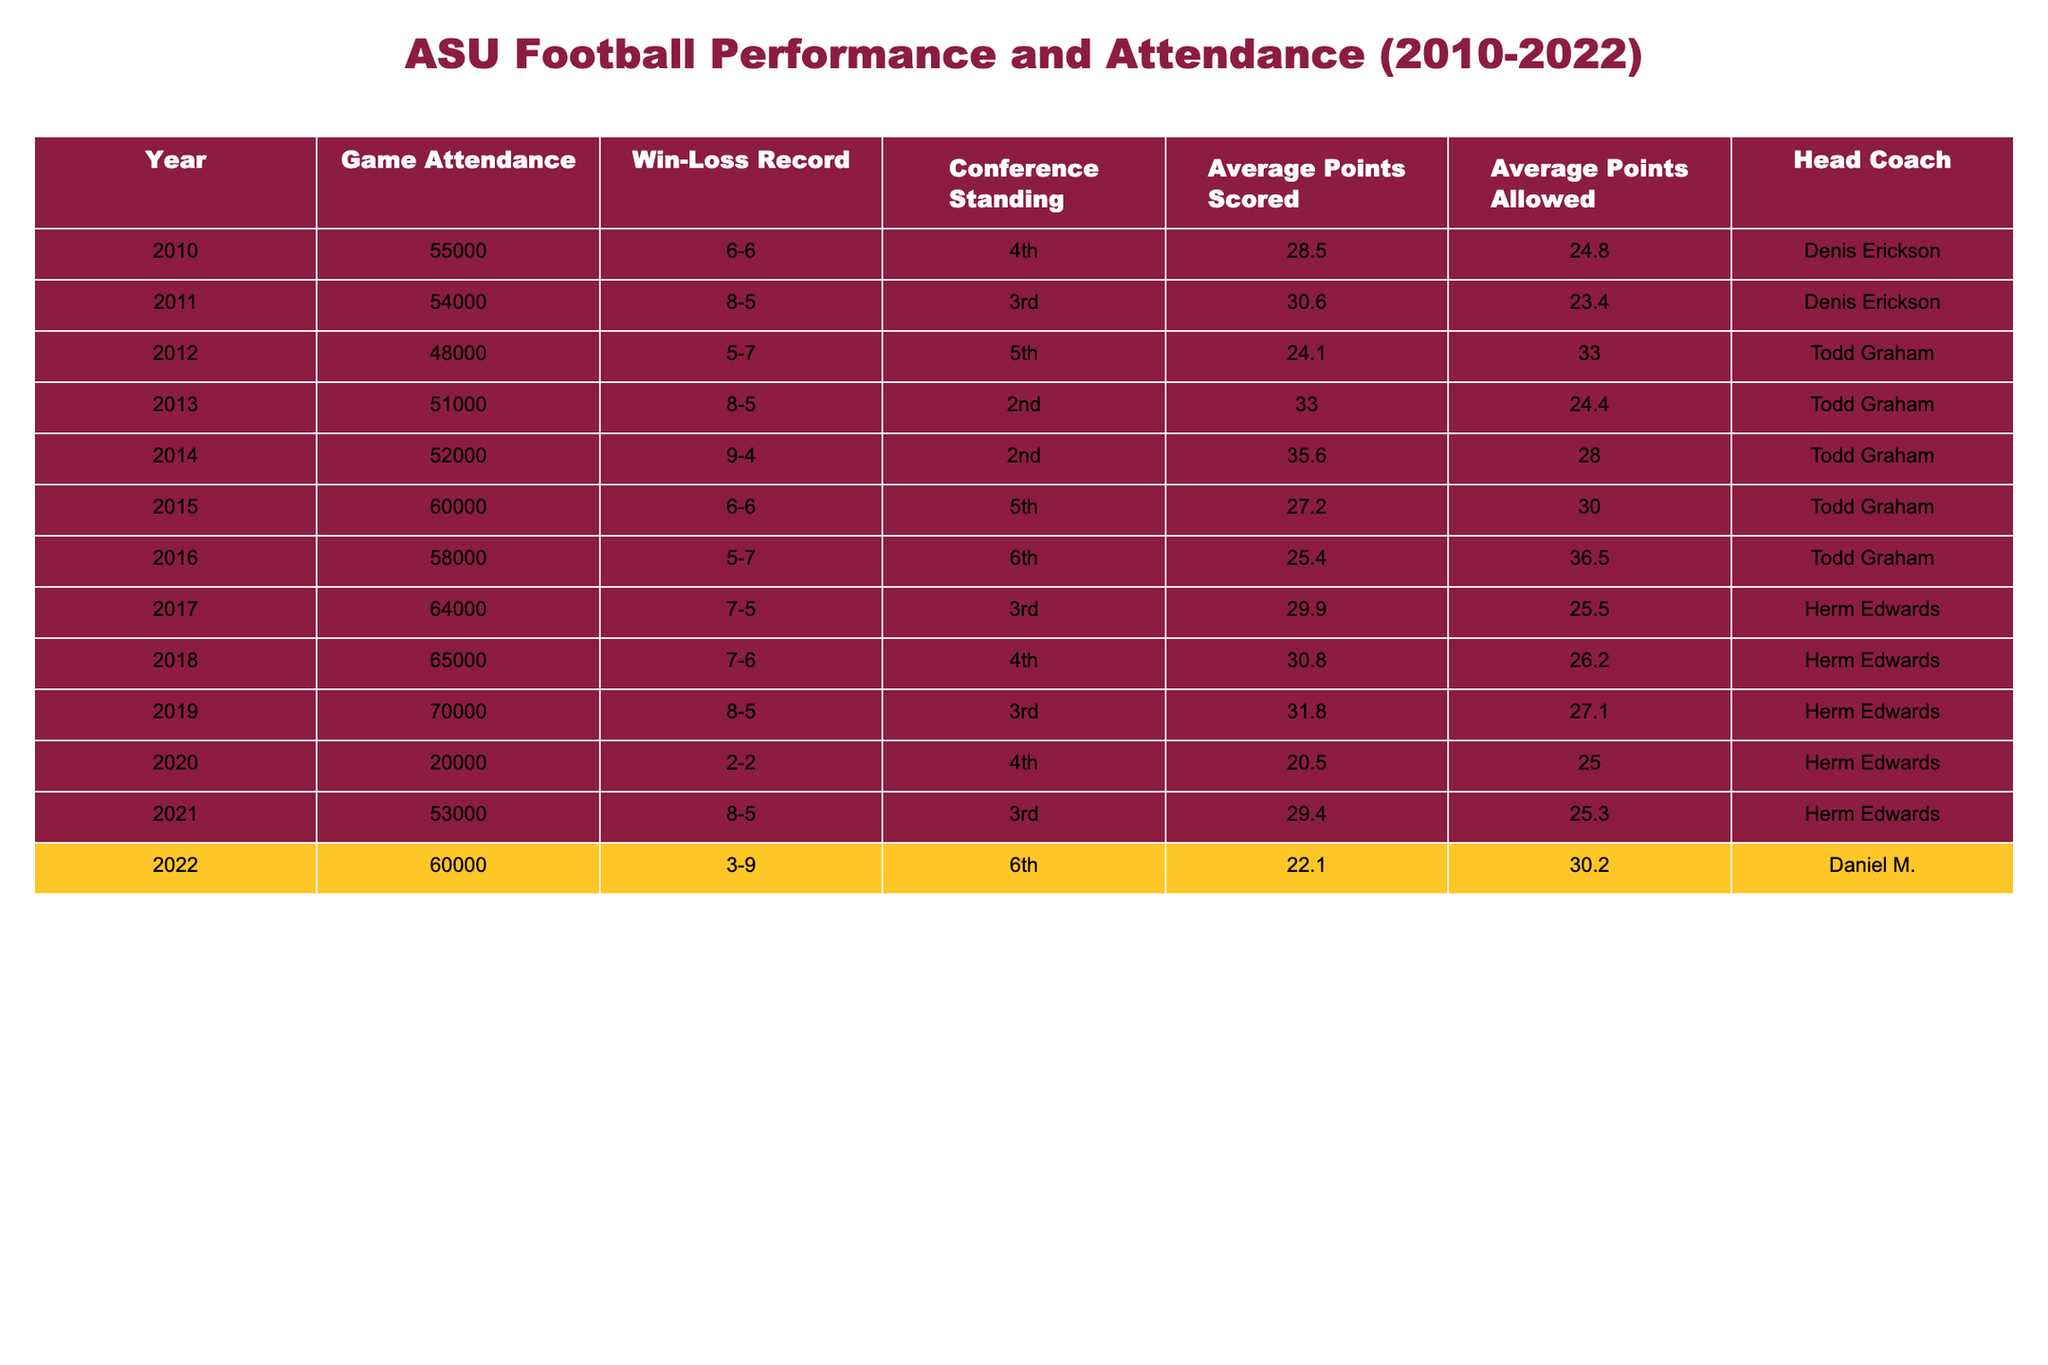What was the highest game attendance recorded in the table? The highest game attendance in the table can be found by scanning through the "Game Attendance" column. The maximum value present is 70000 in the year 2019.
Answer: 70000 In which year did ASU have a win-loss record of 2-2, and how many fans attended that year? Looking through the table, the year with a win-loss record of 2-2 is 2020, and the corresponding game attendance is 20000.
Answer: 2020, 20000 What is the average points scored by ASU over the years listed? To calculate the average points scored, sum the "Average Points Scored" values: (28.5 + 30.6 + 24.1 + 33.0 + 35.6 + 27.2 + 29.9 + 30.8 + 31.8 + 20.5 + 29.4 + 22.1) =  327.1. Then divide by the number of years (12): 327.1 / 12 ≈ 27.26.
Answer: 27.26 What was the average game attendance for the years when ASU finished with a winning record (above .500)? The winning records (above .500) were in the years: 2011, 2013, 2014, 2017, 2018, 2019, and 2021. The corresponding attendances are: 54000, 51000, 52000, 64000, 65000, 70000, and 53000. Sum these attendances (54000 + 51000 + 52000 + 64000 + 65000 + 70000 + 53000 = 419000) and divide by 7 (the number of winning years): 419000 / 7 ≈ 59857.
Answer: 59857 Did ASU's game attendance correlate positively with their winning records overall? Observing the attendance and win-loss records, higher attendance generally aligns with winning records (for example, 2014 and 2019). Conversely, significantly lower attendance coincides with losing records (e.g., 2020 and 2022). Therefore, we can conclude there is a positive correlation observed.
Answer: Yes How many coaches were present during the years with an attendance above 60000? The years with attendance above 60000 are 2015, 2017, 2018, 2019, and 2021. The coaches for those years are Todd Graham (2015), Herm Edwards (2017, 2018, 2019), and Herm Edwards again (2021). This totals to 2 different coaches across those years.
Answer: 2 What year had the best average points scored and what was that score? To find the best average points scored, scan the "Average Points Scored" column. The highest average score is 35.6 in 2014.
Answer: 2014, 35.6 Which year showed a decline in both attendance and performance (indicated by a worsening win-loss record)? By examining the years, 2020 shows a notable decline in attendance (20000) and a win-loss record of 2-2, indicating poor performance relative to previous years.
Answer: 2020 